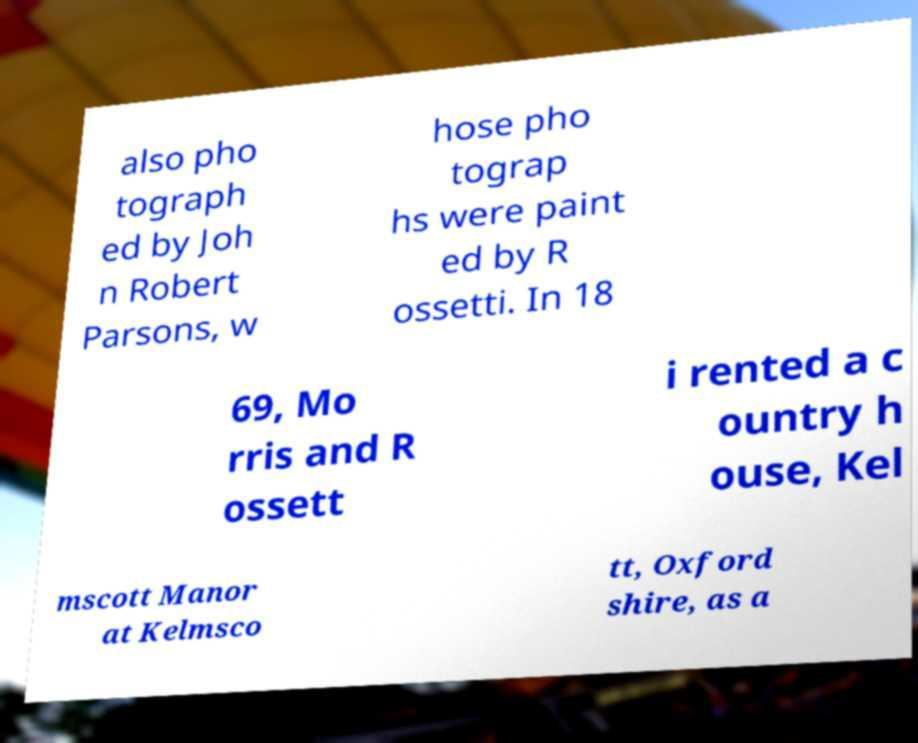Can you accurately transcribe the text from the provided image for me? also pho tograph ed by Joh n Robert Parsons, w hose pho tograp hs were paint ed by R ossetti. In 18 69, Mo rris and R ossett i rented a c ountry h ouse, Kel mscott Manor at Kelmsco tt, Oxford shire, as a 